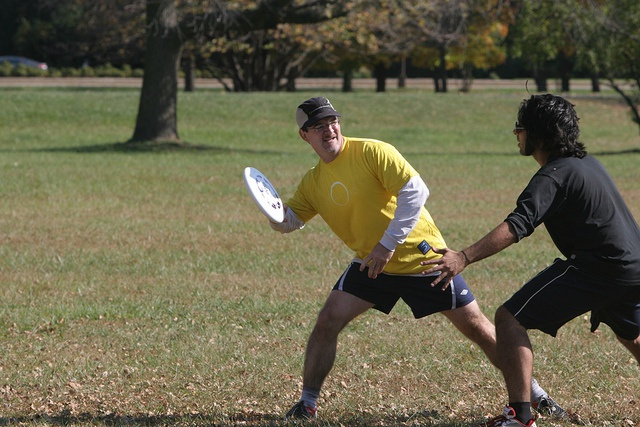Describe the objects in this image and their specific colors. I can see people in black and gray tones, people in black, olive, and gray tones, frisbee in black, white, darkgray, and gray tones, and car in black, gray, navy, and darkblue tones in this image. 